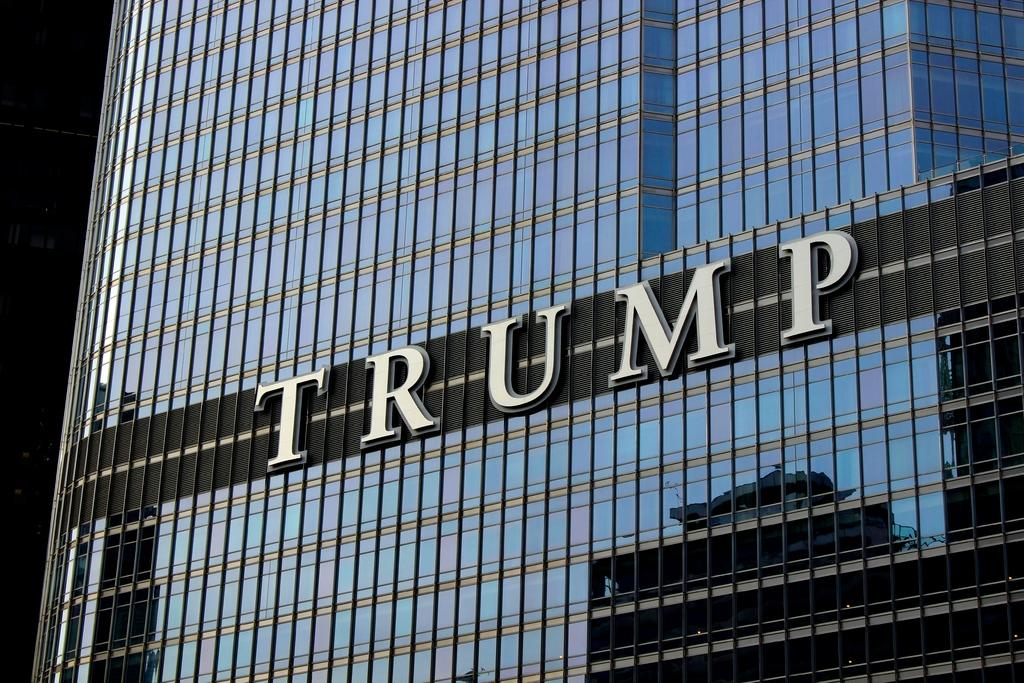What type of structure is visible in the image? There is a building in the image. What else can be seen in the image besides the building? There is a board in the image. How many geese are sitting on the board in the image? There are no geese present in the image; it only features a building and a board. What type of card is being used to prop up the board in the image? There is no card visible in the image; only a building and a board are present. 